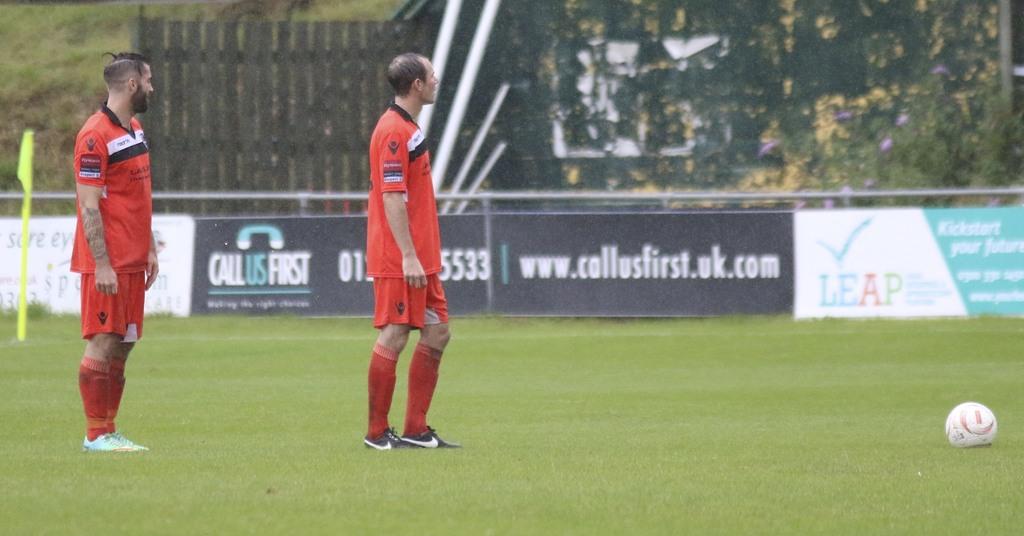What website is on the wall?
Keep it short and to the point. Www.callusfirst.uk.com. 